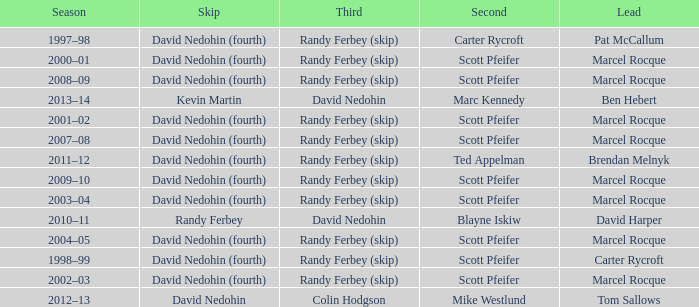Which Second has a Third of david nedohin, and a Lead of ben hebert? Marc Kennedy. 